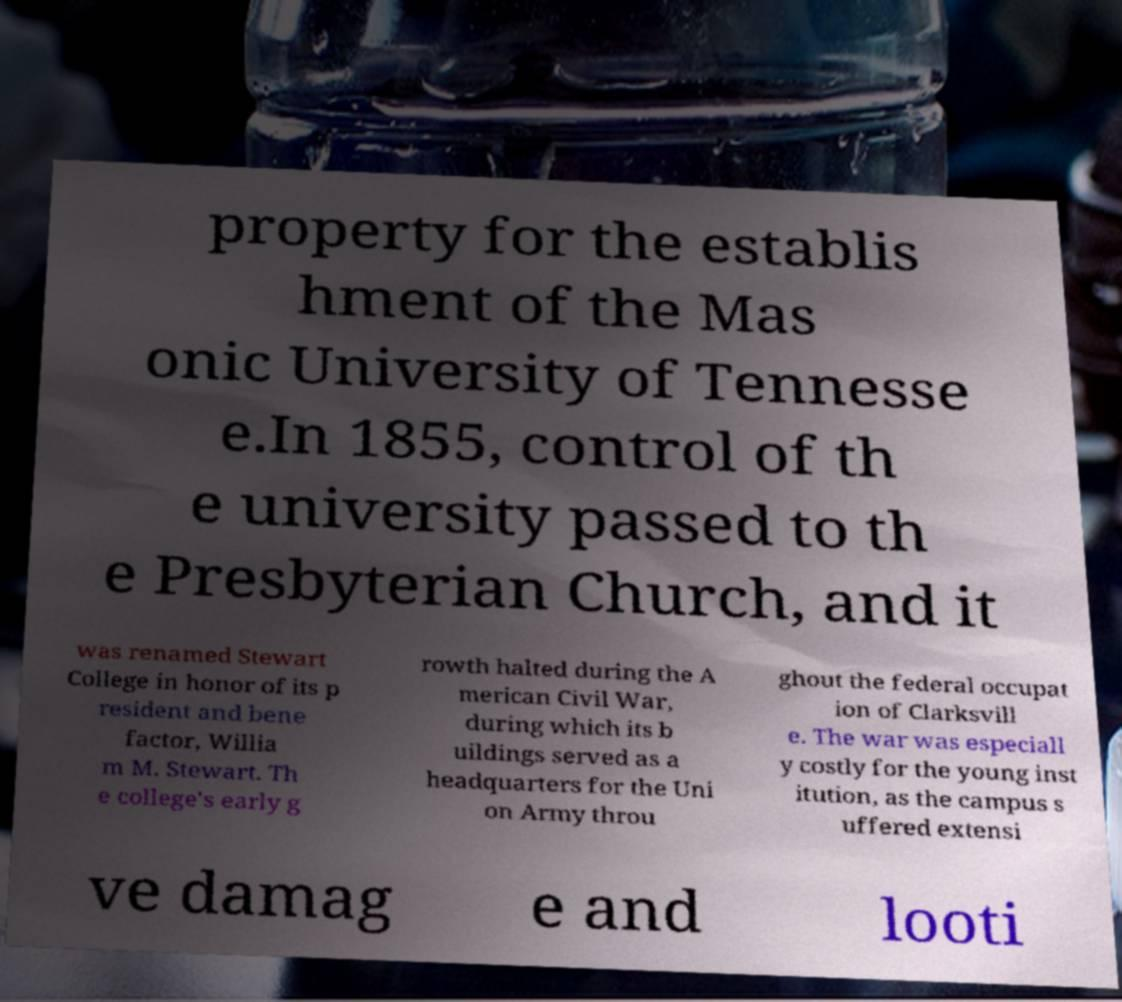Could you assist in decoding the text presented in this image and type it out clearly? property for the establis hment of the Mas onic University of Tennesse e.In 1855, control of th e university passed to th e Presbyterian Church, and it was renamed Stewart College in honor of its p resident and bene factor, Willia m M. Stewart. Th e college's early g rowth halted during the A merican Civil War, during which its b uildings served as a headquarters for the Uni on Army throu ghout the federal occupat ion of Clarksvill e. The war was especiall y costly for the young inst itution, as the campus s uffered extensi ve damag e and looti 